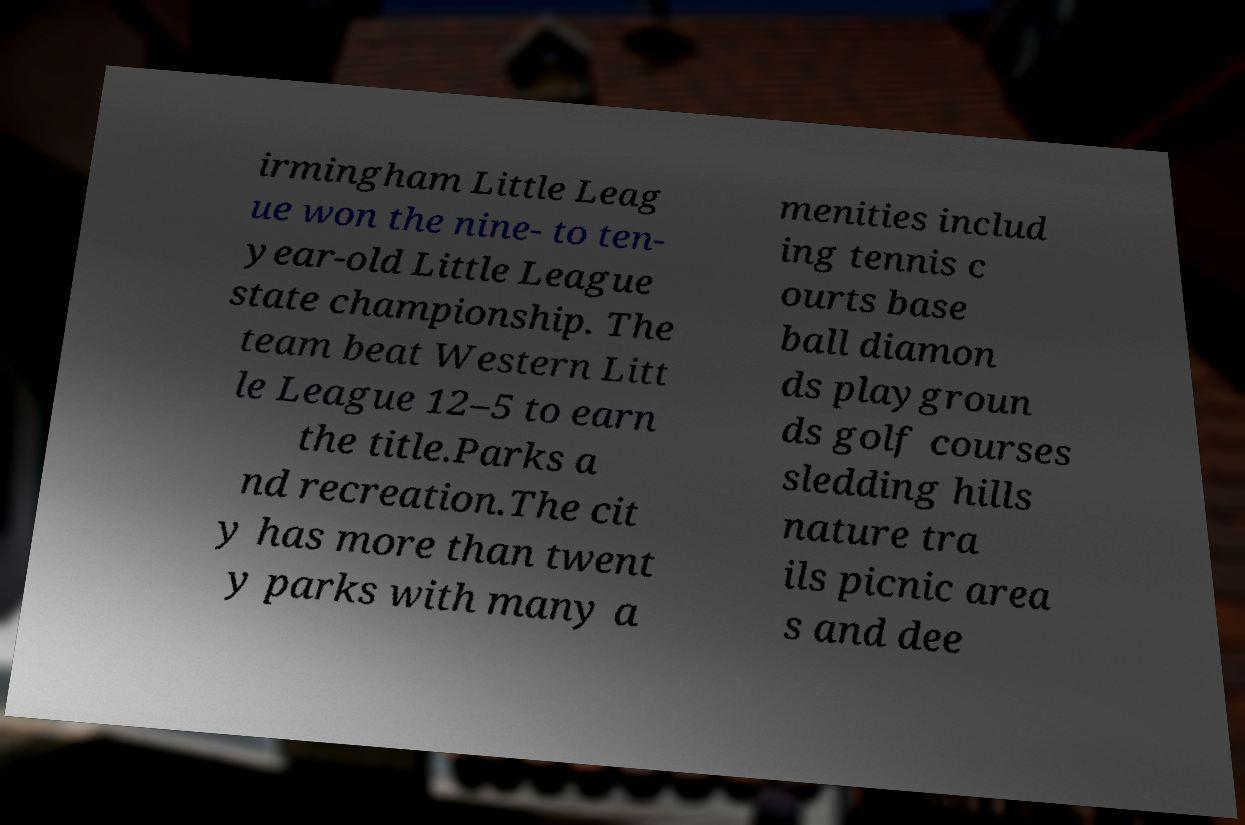I need the written content from this picture converted into text. Can you do that? irmingham Little Leag ue won the nine- to ten- year-old Little League state championship. The team beat Western Litt le League 12–5 to earn the title.Parks a nd recreation.The cit y has more than twent y parks with many a menities includ ing tennis c ourts base ball diamon ds playgroun ds golf courses sledding hills nature tra ils picnic area s and dee 